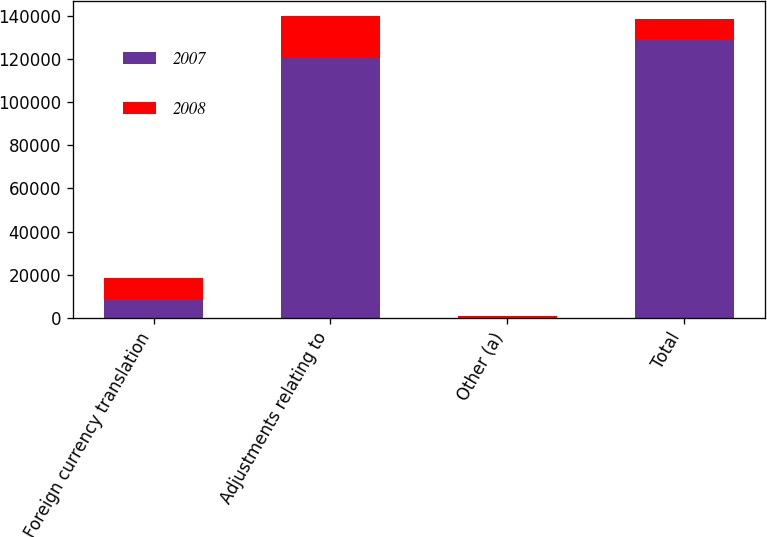Convert chart. <chart><loc_0><loc_0><loc_500><loc_500><stacked_bar_chart><ecel><fcel>Foreign currency translation<fcel>Adjustments relating to<fcel>Other (a)<fcel>Total<nl><fcel>2007<fcel>8819<fcel>120301<fcel>150<fcel>129270<nl><fcel>2008<fcel>9837<fcel>19726<fcel>509<fcel>9380<nl></chart> 